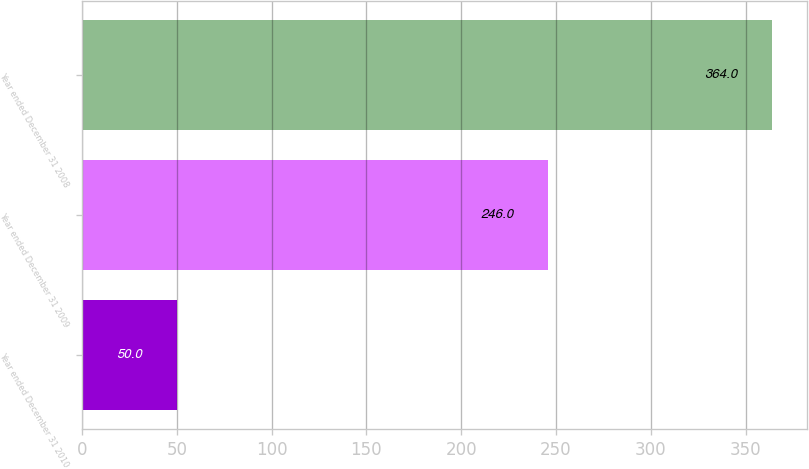Convert chart. <chart><loc_0><loc_0><loc_500><loc_500><bar_chart><fcel>Year ended December 31 2010<fcel>Year ended December 31 2009<fcel>Year ended December 31 2008<nl><fcel>50<fcel>246<fcel>364<nl></chart> 